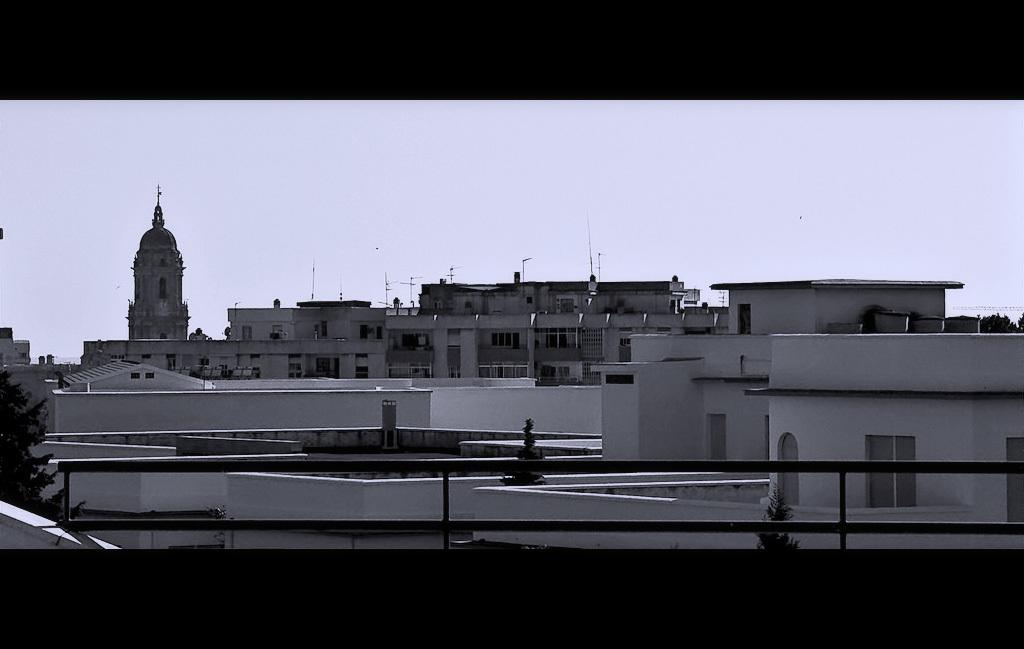What type of structures can be seen in the image? There are buildings in the image. Can you identify any specific type of building in the image? Yes, there is a historical building in the image. How is the historical building situated in relation to other buildings? The historical building is beside other buildings. What can be seen in the background of the image? The sky is visible in the background of the image. What type of metal is used to construct the lunchroom in the image? There is no lunchroom present in the image, so it is not possible to determine what type of metal might be used in its construction. 